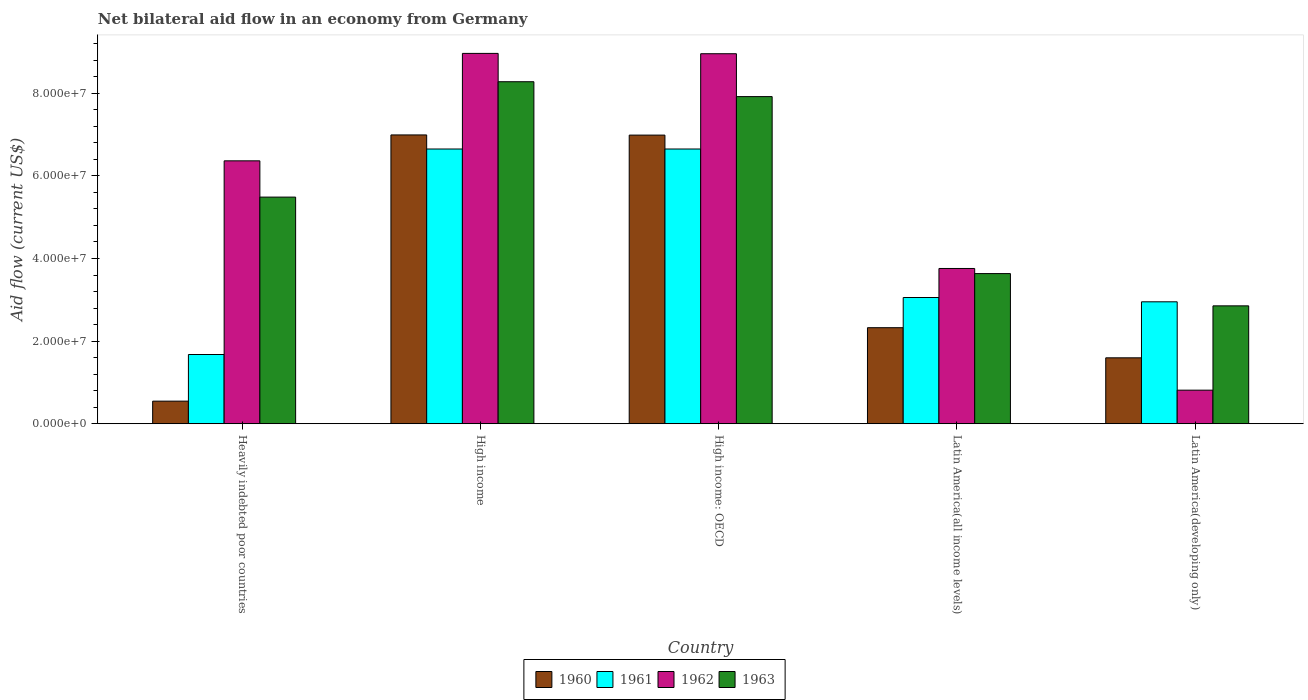How many different coloured bars are there?
Offer a terse response. 4. Are the number of bars per tick equal to the number of legend labels?
Give a very brief answer. Yes. Are the number of bars on each tick of the X-axis equal?
Offer a terse response. Yes. What is the label of the 3rd group of bars from the left?
Your answer should be compact. High income: OECD. What is the net bilateral aid flow in 1963 in Latin America(all income levels)?
Your response must be concise. 3.64e+07. Across all countries, what is the maximum net bilateral aid flow in 1963?
Keep it short and to the point. 8.28e+07. Across all countries, what is the minimum net bilateral aid flow in 1963?
Make the answer very short. 2.85e+07. In which country was the net bilateral aid flow in 1963 minimum?
Ensure brevity in your answer.  Latin America(developing only). What is the total net bilateral aid flow in 1962 in the graph?
Provide a short and direct response. 2.89e+08. What is the difference between the net bilateral aid flow in 1962 in Heavily indebted poor countries and that in Latin America(developing only)?
Ensure brevity in your answer.  5.55e+07. What is the difference between the net bilateral aid flow in 1962 in High income and the net bilateral aid flow in 1960 in High income: OECD?
Provide a succinct answer. 1.98e+07. What is the average net bilateral aid flow in 1960 per country?
Your answer should be very brief. 3.69e+07. What is the difference between the net bilateral aid flow of/in 1963 and net bilateral aid flow of/in 1962 in High income?
Offer a very short reply. -6.86e+06. What is the ratio of the net bilateral aid flow in 1962 in Latin America(all income levels) to that in Latin America(developing only)?
Offer a very short reply. 4.62. Is the net bilateral aid flow in 1961 in Heavily indebted poor countries less than that in Latin America(all income levels)?
Provide a succinct answer. Yes. What is the difference between the highest and the second highest net bilateral aid flow in 1963?
Offer a very short reply. 3.60e+06. What is the difference between the highest and the lowest net bilateral aid flow in 1962?
Give a very brief answer. 8.15e+07. In how many countries, is the net bilateral aid flow in 1961 greater than the average net bilateral aid flow in 1961 taken over all countries?
Offer a very short reply. 2. Is it the case that in every country, the sum of the net bilateral aid flow in 1961 and net bilateral aid flow in 1963 is greater than the sum of net bilateral aid flow in 1962 and net bilateral aid flow in 1960?
Your answer should be very brief. No. What does the 2nd bar from the left in High income: OECD represents?
Keep it short and to the point. 1961. What does the 3rd bar from the right in Latin America(developing only) represents?
Give a very brief answer. 1961. Is it the case that in every country, the sum of the net bilateral aid flow in 1961 and net bilateral aid flow in 1960 is greater than the net bilateral aid flow in 1962?
Your response must be concise. No. How many countries are there in the graph?
Provide a short and direct response. 5. Does the graph contain grids?
Provide a short and direct response. No. What is the title of the graph?
Provide a short and direct response. Net bilateral aid flow in an economy from Germany. What is the label or title of the Y-axis?
Ensure brevity in your answer.  Aid flow (current US$). What is the Aid flow (current US$) of 1960 in Heavily indebted poor countries?
Provide a short and direct response. 5.47e+06. What is the Aid flow (current US$) of 1961 in Heavily indebted poor countries?
Your answer should be very brief. 1.68e+07. What is the Aid flow (current US$) of 1962 in Heavily indebted poor countries?
Offer a very short reply. 6.36e+07. What is the Aid flow (current US$) in 1963 in Heavily indebted poor countries?
Keep it short and to the point. 5.49e+07. What is the Aid flow (current US$) of 1960 in High income?
Keep it short and to the point. 6.99e+07. What is the Aid flow (current US$) in 1961 in High income?
Make the answer very short. 6.65e+07. What is the Aid flow (current US$) in 1962 in High income?
Offer a very short reply. 8.97e+07. What is the Aid flow (current US$) of 1963 in High income?
Offer a very short reply. 8.28e+07. What is the Aid flow (current US$) in 1960 in High income: OECD?
Provide a succinct answer. 6.99e+07. What is the Aid flow (current US$) in 1961 in High income: OECD?
Your response must be concise. 6.65e+07. What is the Aid flow (current US$) of 1962 in High income: OECD?
Keep it short and to the point. 8.96e+07. What is the Aid flow (current US$) in 1963 in High income: OECD?
Make the answer very short. 7.92e+07. What is the Aid flow (current US$) of 1960 in Latin America(all income levels)?
Your answer should be compact. 2.32e+07. What is the Aid flow (current US$) in 1961 in Latin America(all income levels)?
Keep it short and to the point. 3.06e+07. What is the Aid flow (current US$) in 1962 in Latin America(all income levels)?
Offer a terse response. 3.76e+07. What is the Aid flow (current US$) in 1963 in Latin America(all income levels)?
Provide a short and direct response. 3.64e+07. What is the Aid flow (current US$) in 1960 in Latin America(developing only)?
Offer a terse response. 1.60e+07. What is the Aid flow (current US$) in 1961 in Latin America(developing only)?
Give a very brief answer. 2.95e+07. What is the Aid flow (current US$) of 1962 in Latin America(developing only)?
Make the answer very short. 8.13e+06. What is the Aid flow (current US$) of 1963 in Latin America(developing only)?
Give a very brief answer. 2.85e+07. Across all countries, what is the maximum Aid flow (current US$) of 1960?
Provide a short and direct response. 6.99e+07. Across all countries, what is the maximum Aid flow (current US$) of 1961?
Your answer should be compact. 6.65e+07. Across all countries, what is the maximum Aid flow (current US$) of 1962?
Offer a very short reply. 8.97e+07. Across all countries, what is the maximum Aid flow (current US$) of 1963?
Ensure brevity in your answer.  8.28e+07. Across all countries, what is the minimum Aid flow (current US$) in 1960?
Your answer should be compact. 5.47e+06. Across all countries, what is the minimum Aid flow (current US$) of 1961?
Give a very brief answer. 1.68e+07. Across all countries, what is the minimum Aid flow (current US$) of 1962?
Give a very brief answer. 8.13e+06. Across all countries, what is the minimum Aid flow (current US$) in 1963?
Offer a very short reply. 2.85e+07. What is the total Aid flow (current US$) in 1960 in the graph?
Keep it short and to the point. 1.84e+08. What is the total Aid flow (current US$) of 1961 in the graph?
Provide a short and direct response. 2.10e+08. What is the total Aid flow (current US$) in 1962 in the graph?
Keep it short and to the point. 2.89e+08. What is the total Aid flow (current US$) of 1963 in the graph?
Offer a very short reply. 2.82e+08. What is the difference between the Aid flow (current US$) in 1960 in Heavily indebted poor countries and that in High income?
Offer a very short reply. -6.44e+07. What is the difference between the Aid flow (current US$) of 1961 in Heavily indebted poor countries and that in High income?
Your answer should be very brief. -4.98e+07. What is the difference between the Aid flow (current US$) in 1962 in Heavily indebted poor countries and that in High income?
Your answer should be very brief. -2.60e+07. What is the difference between the Aid flow (current US$) in 1963 in Heavily indebted poor countries and that in High income?
Your response must be concise. -2.79e+07. What is the difference between the Aid flow (current US$) in 1960 in Heavily indebted poor countries and that in High income: OECD?
Your response must be concise. -6.44e+07. What is the difference between the Aid flow (current US$) of 1961 in Heavily indebted poor countries and that in High income: OECD?
Provide a succinct answer. -4.98e+07. What is the difference between the Aid flow (current US$) of 1962 in Heavily indebted poor countries and that in High income: OECD?
Your answer should be very brief. -2.59e+07. What is the difference between the Aid flow (current US$) of 1963 in Heavily indebted poor countries and that in High income: OECD?
Keep it short and to the point. -2.43e+07. What is the difference between the Aid flow (current US$) in 1960 in Heavily indebted poor countries and that in Latin America(all income levels)?
Offer a terse response. -1.78e+07. What is the difference between the Aid flow (current US$) in 1961 in Heavily indebted poor countries and that in Latin America(all income levels)?
Offer a very short reply. -1.38e+07. What is the difference between the Aid flow (current US$) in 1962 in Heavily indebted poor countries and that in Latin America(all income levels)?
Your response must be concise. 2.61e+07. What is the difference between the Aid flow (current US$) in 1963 in Heavily indebted poor countries and that in Latin America(all income levels)?
Offer a very short reply. 1.85e+07. What is the difference between the Aid flow (current US$) in 1960 in Heavily indebted poor countries and that in Latin America(developing only)?
Your response must be concise. -1.05e+07. What is the difference between the Aid flow (current US$) of 1961 in Heavily indebted poor countries and that in Latin America(developing only)?
Make the answer very short. -1.28e+07. What is the difference between the Aid flow (current US$) in 1962 in Heavily indebted poor countries and that in Latin America(developing only)?
Provide a succinct answer. 5.55e+07. What is the difference between the Aid flow (current US$) of 1963 in Heavily indebted poor countries and that in Latin America(developing only)?
Give a very brief answer. 2.63e+07. What is the difference between the Aid flow (current US$) in 1960 in High income and that in High income: OECD?
Offer a terse response. 4.00e+04. What is the difference between the Aid flow (current US$) in 1963 in High income and that in High income: OECD?
Provide a short and direct response. 3.60e+06. What is the difference between the Aid flow (current US$) in 1960 in High income and that in Latin America(all income levels)?
Make the answer very short. 4.67e+07. What is the difference between the Aid flow (current US$) in 1961 in High income and that in Latin America(all income levels)?
Your answer should be compact. 3.60e+07. What is the difference between the Aid flow (current US$) of 1962 in High income and that in Latin America(all income levels)?
Offer a terse response. 5.21e+07. What is the difference between the Aid flow (current US$) in 1963 in High income and that in Latin America(all income levels)?
Provide a succinct answer. 4.64e+07. What is the difference between the Aid flow (current US$) of 1960 in High income and that in Latin America(developing only)?
Your response must be concise. 5.40e+07. What is the difference between the Aid flow (current US$) in 1961 in High income and that in Latin America(developing only)?
Your answer should be very brief. 3.70e+07. What is the difference between the Aid flow (current US$) of 1962 in High income and that in Latin America(developing only)?
Your answer should be very brief. 8.15e+07. What is the difference between the Aid flow (current US$) in 1963 in High income and that in Latin America(developing only)?
Offer a very short reply. 5.43e+07. What is the difference between the Aid flow (current US$) in 1960 in High income: OECD and that in Latin America(all income levels)?
Offer a terse response. 4.66e+07. What is the difference between the Aid flow (current US$) of 1961 in High income: OECD and that in Latin America(all income levels)?
Make the answer very short. 3.60e+07. What is the difference between the Aid flow (current US$) in 1962 in High income: OECD and that in Latin America(all income levels)?
Your response must be concise. 5.20e+07. What is the difference between the Aid flow (current US$) in 1963 in High income: OECD and that in Latin America(all income levels)?
Offer a terse response. 4.28e+07. What is the difference between the Aid flow (current US$) in 1960 in High income: OECD and that in Latin America(developing only)?
Your answer should be compact. 5.39e+07. What is the difference between the Aid flow (current US$) of 1961 in High income: OECD and that in Latin America(developing only)?
Ensure brevity in your answer.  3.70e+07. What is the difference between the Aid flow (current US$) in 1962 in High income: OECD and that in Latin America(developing only)?
Keep it short and to the point. 8.14e+07. What is the difference between the Aid flow (current US$) in 1963 in High income: OECD and that in Latin America(developing only)?
Offer a terse response. 5.07e+07. What is the difference between the Aid flow (current US$) of 1960 in Latin America(all income levels) and that in Latin America(developing only)?
Provide a short and direct response. 7.29e+06. What is the difference between the Aid flow (current US$) of 1961 in Latin America(all income levels) and that in Latin America(developing only)?
Make the answer very short. 1.04e+06. What is the difference between the Aid flow (current US$) in 1962 in Latin America(all income levels) and that in Latin America(developing only)?
Offer a very short reply. 2.95e+07. What is the difference between the Aid flow (current US$) in 1963 in Latin America(all income levels) and that in Latin America(developing only)?
Provide a short and direct response. 7.81e+06. What is the difference between the Aid flow (current US$) in 1960 in Heavily indebted poor countries and the Aid flow (current US$) in 1961 in High income?
Provide a short and direct response. -6.10e+07. What is the difference between the Aid flow (current US$) of 1960 in Heavily indebted poor countries and the Aid flow (current US$) of 1962 in High income?
Ensure brevity in your answer.  -8.42e+07. What is the difference between the Aid flow (current US$) of 1960 in Heavily indebted poor countries and the Aid flow (current US$) of 1963 in High income?
Your answer should be very brief. -7.73e+07. What is the difference between the Aid flow (current US$) of 1961 in Heavily indebted poor countries and the Aid flow (current US$) of 1962 in High income?
Provide a succinct answer. -7.29e+07. What is the difference between the Aid flow (current US$) of 1961 in Heavily indebted poor countries and the Aid flow (current US$) of 1963 in High income?
Offer a very short reply. -6.60e+07. What is the difference between the Aid flow (current US$) in 1962 in Heavily indebted poor countries and the Aid flow (current US$) in 1963 in High income?
Your answer should be compact. -1.92e+07. What is the difference between the Aid flow (current US$) of 1960 in Heavily indebted poor countries and the Aid flow (current US$) of 1961 in High income: OECD?
Ensure brevity in your answer.  -6.10e+07. What is the difference between the Aid flow (current US$) in 1960 in Heavily indebted poor countries and the Aid flow (current US$) in 1962 in High income: OECD?
Offer a terse response. -8.41e+07. What is the difference between the Aid flow (current US$) of 1960 in Heavily indebted poor countries and the Aid flow (current US$) of 1963 in High income: OECD?
Provide a short and direct response. -7.37e+07. What is the difference between the Aid flow (current US$) of 1961 in Heavily indebted poor countries and the Aid flow (current US$) of 1962 in High income: OECD?
Your response must be concise. -7.28e+07. What is the difference between the Aid flow (current US$) in 1961 in Heavily indebted poor countries and the Aid flow (current US$) in 1963 in High income: OECD?
Provide a succinct answer. -6.24e+07. What is the difference between the Aid flow (current US$) in 1962 in Heavily indebted poor countries and the Aid flow (current US$) in 1963 in High income: OECD?
Make the answer very short. -1.56e+07. What is the difference between the Aid flow (current US$) of 1960 in Heavily indebted poor countries and the Aid flow (current US$) of 1961 in Latin America(all income levels)?
Your answer should be very brief. -2.51e+07. What is the difference between the Aid flow (current US$) in 1960 in Heavily indebted poor countries and the Aid flow (current US$) in 1962 in Latin America(all income levels)?
Make the answer very short. -3.21e+07. What is the difference between the Aid flow (current US$) in 1960 in Heavily indebted poor countries and the Aid flow (current US$) in 1963 in Latin America(all income levels)?
Offer a very short reply. -3.09e+07. What is the difference between the Aid flow (current US$) in 1961 in Heavily indebted poor countries and the Aid flow (current US$) in 1962 in Latin America(all income levels)?
Your answer should be very brief. -2.08e+07. What is the difference between the Aid flow (current US$) in 1961 in Heavily indebted poor countries and the Aid flow (current US$) in 1963 in Latin America(all income levels)?
Provide a succinct answer. -1.96e+07. What is the difference between the Aid flow (current US$) in 1962 in Heavily indebted poor countries and the Aid flow (current US$) in 1963 in Latin America(all income levels)?
Provide a succinct answer. 2.73e+07. What is the difference between the Aid flow (current US$) in 1960 in Heavily indebted poor countries and the Aid flow (current US$) in 1961 in Latin America(developing only)?
Your response must be concise. -2.40e+07. What is the difference between the Aid flow (current US$) in 1960 in Heavily indebted poor countries and the Aid flow (current US$) in 1962 in Latin America(developing only)?
Your response must be concise. -2.66e+06. What is the difference between the Aid flow (current US$) of 1960 in Heavily indebted poor countries and the Aid flow (current US$) of 1963 in Latin America(developing only)?
Give a very brief answer. -2.31e+07. What is the difference between the Aid flow (current US$) of 1961 in Heavily indebted poor countries and the Aid flow (current US$) of 1962 in Latin America(developing only)?
Your response must be concise. 8.63e+06. What is the difference between the Aid flow (current US$) of 1961 in Heavily indebted poor countries and the Aid flow (current US$) of 1963 in Latin America(developing only)?
Provide a short and direct response. -1.18e+07. What is the difference between the Aid flow (current US$) of 1962 in Heavily indebted poor countries and the Aid flow (current US$) of 1963 in Latin America(developing only)?
Keep it short and to the point. 3.51e+07. What is the difference between the Aid flow (current US$) of 1960 in High income and the Aid flow (current US$) of 1961 in High income: OECD?
Offer a very short reply. 3.41e+06. What is the difference between the Aid flow (current US$) in 1960 in High income and the Aid flow (current US$) in 1962 in High income: OECD?
Give a very brief answer. -1.97e+07. What is the difference between the Aid flow (current US$) of 1960 in High income and the Aid flow (current US$) of 1963 in High income: OECD?
Your answer should be compact. -9.28e+06. What is the difference between the Aid flow (current US$) in 1961 in High income and the Aid flow (current US$) in 1962 in High income: OECD?
Offer a very short reply. -2.31e+07. What is the difference between the Aid flow (current US$) in 1961 in High income and the Aid flow (current US$) in 1963 in High income: OECD?
Provide a succinct answer. -1.27e+07. What is the difference between the Aid flow (current US$) in 1962 in High income and the Aid flow (current US$) in 1963 in High income: OECD?
Ensure brevity in your answer.  1.05e+07. What is the difference between the Aid flow (current US$) in 1960 in High income and the Aid flow (current US$) in 1961 in Latin America(all income levels)?
Ensure brevity in your answer.  3.94e+07. What is the difference between the Aid flow (current US$) of 1960 in High income and the Aid flow (current US$) of 1962 in Latin America(all income levels)?
Provide a short and direct response. 3.23e+07. What is the difference between the Aid flow (current US$) of 1960 in High income and the Aid flow (current US$) of 1963 in Latin America(all income levels)?
Your answer should be compact. 3.36e+07. What is the difference between the Aid flow (current US$) in 1961 in High income and the Aid flow (current US$) in 1962 in Latin America(all income levels)?
Keep it short and to the point. 2.89e+07. What is the difference between the Aid flow (current US$) of 1961 in High income and the Aid flow (current US$) of 1963 in Latin America(all income levels)?
Your answer should be very brief. 3.02e+07. What is the difference between the Aid flow (current US$) in 1962 in High income and the Aid flow (current US$) in 1963 in Latin America(all income levels)?
Offer a terse response. 5.33e+07. What is the difference between the Aid flow (current US$) of 1960 in High income and the Aid flow (current US$) of 1961 in Latin America(developing only)?
Keep it short and to the point. 4.04e+07. What is the difference between the Aid flow (current US$) of 1960 in High income and the Aid flow (current US$) of 1962 in Latin America(developing only)?
Provide a succinct answer. 6.18e+07. What is the difference between the Aid flow (current US$) in 1960 in High income and the Aid flow (current US$) in 1963 in Latin America(developing only)?
Offer a terse response. 4.14e+07. What is the difference between the Aid flow (current US$) of 1961 in High income and the Aid flow (current US$) of 1962 in Latin America(developing only)?
Offer a terse response. 5.84e+07. What is the difference between the Aid flow (current US$) of 1961 in High income and the Aid flow (current US$) of 1963 in Latin America(developing only)?
Keep it short and to the point. 3.80e+07. What is the difference between the Aid flow (current US$) of 1962 in High income and the Aid flow (current US$) of 1963 in Latin America(developing only)?
Make the answer very short. 6.11e+07. What is the difference between the Aid flow (current US$) in 1960 in High income: OECD and the Aid flow (current US$) in 1961 in Latin America(all income levels)?
Provide a short and direct response. 3.93e+07. What is the difference between the Aid flow (current US$) in 1960 in High income: OECD and the Aid flow (current US$) in 1962 in Latin America(all income levels)?
Offer a terse response. 3.23e+07. What is the difference between the Aid flow (current US$) in 1960 in High income: OECD and the Aid flow (current US$) in 1963 in Latin America(all income levels)?
Keep it short and to the point. 3.35e+07. What is the difference between the Aid flow (current US$) of 1961 in High income: OECD and the Aid flow (current US$) of 1962 in Latin America(all income levels)?
Give a very brief answer. 2.89e+07. What is the difference between the Aid flow (current US$) of 1961 in High income: OECD and the Aid flow (current US$) of 1963 in Latin America(all income levels)?
Make the answer very short. 3.02e+07. What is the difference between the Aid flow (current US$) in 1962 in High income: OECD and the Aid flow (current US$) in 1963 in Latin America(all income levels)?
Keep it short and to the point. 5.32e+07. What is the difference between the Aid flow (current US$) of 1960 in High income: OECD and the Aid flow (current US$) of 1961 in Latin America(developing only)?
Provide a succinct answer. 4.04e+07. What is the difference between the Aid flow (current US$) of 1960 in High income: OECD and the Aid flow (current US$) of 1962 in Latin America(developing only)?
Your response must be concise. 6.18e+07. What is the difference between the Aid flow (current US$) of 1960 in High income: OECD and the Aid flow (current US$) of 1963 in Latin America(developing only)?
Your answer should be very brief. 4.13e+07. What is the difference between the Aid flow (current US$) of 1961 in High income: OECD and the Aid flow (current US$) of 1962 in Latin America(developing only)?
Keep it short and to the point. 5.84e+07. What is the difference between the Aid flow (current US$) in 1961 in High income: OECD and the Aid flow (current US$) in 1963 in Latin America(developing only)?
Keep it short and to the point. 3.80e+07. What is the difference between the Aid flow (current US$) in 1962 in High income: OECD and the Aid flow (current US$) in 1963 in Latin America(developing only)?
Offer a terse response. 6.10e+07. What is the difference between the Aid flow (current US$) of 1960 in Latin America(all income levels) and the Aid flow (current US$) of 1961 in Latin America(developing only)?
Give a very brief answer. -6.27e+06. What is the difference between the Aid flow (current US$) of 1960 in Latin America(all income levels) and the Aid flow (current US$) of 1962 in Latin America(developing only)?
Provide a short and direct response. 1.51e+07. What is the difference between the Aid flow (current US$) of 1960 in Latin America(all income levels) and the Aid flow (current US$) of 1963 in Latin America(developing only)?
Your response must be concise. -5.29e+06. What is the difference between the Aid flow (current US$) of 1961 in Latin America(all income levels) and the Aid flow (current US$) of 1962 in Latin America(developing only)?
Your answer should be compact. 2.24e+07. What is the difference between the Aid flow (current US$) in 1961 in Latin America(all income levels) and the Aid flow (current US$) in 1963 in Latin America(developing only)?
Your response must be concise. 2.02e+06. What is the difference between the Aid flow (current US$) in 1962 in Latin America(all income levels) and the Aid flow (current US$) in 1963 in Latin America(developing only)?
Your response must be concise. 9.05e+06. What is the average Aid flow (current US$) in 1960 per country?
Your answer should be very brief. 3.69e+07. What is the average Aid flow (current US$) of 1961 per country?
Provide a succinct answer. 4.20e+07. What is the average Aid flow (current US$) of 1962 per country?
Make the answer very short. 5.77e+07. What is the average Aid flow (current US$) of 1963 per country?
Give a very brief answer. 5.64e+07. What is the difference between the Aid flow (current US$) in 1960 and Aid flow (current US$) in 1961 in Heavily indebted poor countries?
Your response must be concise. -1.13e+07. What is the difference between the Aid flow (current US$) of 1960 and Aid flow (current US$) of 1962 in Heavily indebted poor countries?
Give a very brief answer. -5.82e+07. What is the difference between the Aid flow (current US$) of 1960 and Aid flow (current US$) of 1963 in Heavily indebted poor countries?
Your response must be concise. -4.94e+07. What is the difference between the Aid flow (current US$) of 1961 and Aid flow (current US$) of 1962 in Heavily indebted poor countries?
Provide a succinct answer. -4.69e+07. What is the difference between the Aid flow (current US$) of 1961 and Aid flow (current US$) of 1963 in Heavily indebted poor countries?
Provide a succinct answer. -3.81e+07. What is the difference between the Aid flow (current US$) of 1962 and Aid flow (current US$) of 1963 in Heavily indebted poor countries?
Your response must be concise. 8.78e+06. What is the difference between the Aid flow (current US$) of 1960 and Aid flow (current US$) of 1961 in High income?
Your response must be concise. 3.41e+06. What is the difference between the Aid flow (current US$) of 1960 and Aid flow (current US$) of 1962 in High income?
Your response must be concise. -1.97e+07. What is the difference between the Aid flow (current US$) in 1960 and Aid flow (current US$) in 1963 in High income?
Give a very brief answer. -1.29e+07. What is the difference between the Aid flow (current US$) in 1961 and Aid flow (current US$) in 1962 in High income?
Offer a terse response. -2.32e+07. What is the difference between the Aid flow (current US$) in 1961 and Aid flow (current US$) in 1963 in High income?
Make the answer very short. -1.63e+07. What is the difference between the Aid flow (current US$) of 1962 and Aid flow (current US$) of 1963 in High income?
Your answer should be compact. 6.86e+06. What is the difference between the Aid flow (current US$) of 1960 and Aid flow (current US$) of 1961 in High income: OECD?
Your answer should be very brief. 3.37e+06. What is the difference between the Aid flow (current US$) of 1960 and Aid flow (current US$) of 1962 in High income: OECD?
Provide a short and direct response. -1.97e+07. What is the difference between the Aid flow (current US$) in 1960 and Aid flow (current US$) in 1963 in High income: OECD?
Your answer should be compact. -9.32e+06. What is the difference between the Aid flow (current US$) of 1961 and Aid flow (current US$) of 1962 in High income: OECD?
Your answer should be compact. -2.31e+07. What is the difference between the Aid flow (current US$) in 1961 and Aid flow (current US$) in 1963 in High income: OECD?
Provide a short and direct response. -1.27e+07. What is the difference between the Aid flow (current US$) of 1962 and Aid flow (current US$) of 1963 in High income: OECD?
Ensure brevity in your answer.  1.04e+07. What is the difference between the Aid flow (current US$) in 1960 and Aid flow (current US$) in 1961 in Latin America(all income levels)?
Offer a terse response. -7.31e+06. What is the difference between the Aid flow (current US$) in 1960 and Aid flow (current US$) in 1962 in Latin America(all income levels)?
Ensure brevity in your answer.  -1.43e+07. What is the difference between the Aid flow (current US$) of 1960 and Aid flow (current US$) of 1963 in Latin America(all income levels)?
Provide a succinct answer. -1.31e+07. What is the difference between the Aid flow (current US$) of 1961 and Aid flow (current US$) of 1962 in Latin America(all income levels)?
Give a very brief answer. -7.03e+06. What is the difference between the Aid flow (current US$) in 1961 and Aid flow (current US$) in 1963 in Latin America(all income levels)?
Make the answer very short. -5.79e+06. What is the difference between the Aid flow (current US$) in 1962 and Aid flow (current US$) in 1963 in Latin America(all income levels)?
Your answer should be very brief. 1.24e+06. What is the difference between the Aid flow (current US$) in 1960 and Aid flow (current US$) in 1961 in Latin America(developing only)?
Make the answer very short. -1.36e+07. What is the difference between the Aid flow (current US$) of 1960 and Aid flow (current US$) of 1962 in Latin America(developing only)?
Your answer should be compact. 7.83e+06. What is the difference between the Aid flow (current US$) of 1960 and Aid flow (current US$) of 1963 in Latin America(developing only)?
Keep it short and to the point. -1.26e+07. What is the difference between the Aid flow (current US$) in 1961 and Aid flow (current US$) in 1962 in Latin America(developing only)?
Keep it short and to the point. 2.14e+07. What is the difference between the Aid flow (current US$) in 1961 and Aid flow (current US$) in 1963 in Latin America(developing only)?
Give a very brief answer. 9.80e+05. What is the difference between the Aid flow (current US$) in 1962 and Aid flow (current US$) in 1963 in Latin America(developing only)?
Offer a very short reply. -2.04e+07. What is the ratio of the Aid flow (current US$) of 1960 in Heavily indebted poor countries to that in High income?
Your answer should be very brief. 0.08. What is the ratio of the Aid flow (current US$) of 1961 in Heavily indebted poor countries to that in High income?
Provide a succinct answer. 0.25. What is the ratio of the Aid flow (current US$) of 1962 in Heavily indebted poor countries to that in High income?
Offer a very short reply. 0.71. What is the ratio of the Aid flow (current US$) of 1963 in Heavily indebted poor countries to that in High income?
Provide a short and direct response. 0.66. What is the ratio of the Aid flow (current US$) of 1960 in Heavily indebted poor countries to that in High income: OECD?
Offer a very short reply. 0.08. What is the ratio of the Aid flow (current US$) of 1961 in Heavily indebted poor countries to that in High income: OECD?
Ensure brevity in your answer.  0.25. What is the ratio of the Aid flow (current US$) in 1962 in Heavily indebted poor countries to that in High income: OECD?
Ensure brevity in your answer.  0.71. What is the ratio of the Aid flow (current US$) in 1963 in Heavily indebted poor countries to that in High income: OECD?
Your answer should be very brief. 0.69. What is the ratio of the Aid flow (current US$) of 1960 in Heavily indebted poor countries to that in Latin America(all income levels)?
Provide a short and direct response. 0.24. What is the ratio of the Aid flow (current US$) of 1961 in Heavily indebted poor countries to that in Latin America(all income levels)?
Offer a terse response. 0.55. What is the ratio of the Aid flow (current US$) in 1962 in Heavily indebted poor countries to that in Latin America(all income levels)?
Your response must be concise. 1.69. What is the ratio of the Aid flow (current US$) of 1963 in Heavily indebted poor countries to that in Latin America(all income levels)?
Make the answer very short. 1.51. What is the ratio of the Aid flow (current US$) in 1960 in Heavily indebted poor countries to that in Latin America(developing only)?
Your answer should be compact. 0.34. What is the ratio of the Aid flow (current US$) in 1961 in Heavily indebted poor countries to that in Latin America(developing only)?
Keep it short and to the point. 0.57. What is the ratio of the Aid flow (current US$) of 1962 in Heavily indebted poor countries to that in Latin America(developing only)?
Your answer should be compact. 7.83. What is the ratio of the Aid flow (current US$) in 1963 in Heavily indebted poor countries to that in Latin America(developing only)?
Keep it short and to the point. 1.92. What is the ratio of the Aid flow (current US$) in 1961 in High income to that in High income: OECD?
Your answer should be compact. 1. What is the ratio of the Aid flow (current US$) of 1962 in High income to that in High income: OECD?
Your answer should be compact. 1. What is the ratio of the Aid flow (current US$) in 1963 in High income to that in High income: OECD?
Provide a short and direct response. 1.05. What is the ratio of the Aid flow (current US$) of 1960 in High income to that in Latin America(all income levels)?
Provide a short and direct response. 3.01. What is the ratio of the Aid flow (current US$) of 1961 in High income to that in Latin America(all income levels)?
Offer a terse response. 2.18. What is the ratio of the Aid flow (current US$) in 1962 in High income to that in Latin America(all income levels)?
Keep it short and to the point. 2.39. What is the ratio of the Aid flow (current US$) in 1963 in High income to that in Latin America(all income levels)?
Make the answer very short. 2.28. What is the ratio of the Aid flow (current US$) in 1960 in High income to that in Latin America(developing only)?
Your answer should be very brief. 4.38. What is the ratio of the Aid flow (current US$) in 1961 in High income to that in Latin America(developing only)?
Offer a very short reply. 2.25. What is the ratio of the Aid flow (current US$) in 1962 in High income to that in Latin America(developing only)?
Ensure brevity in your answer.  11.03. What is the ratio of the Aid flow (current US$) of 1963 in High income to that in Latin America(developing only)?
Provide a succinct answer. 2.9. What is the ratio of the Aid flow (current US$) of 1960 in High income: OECD to that in Latin America(all income levels)?
Your answer should be compact. 3.01. What is the ratio of the Aid flow (current US$) in 1961 in High income: OECD to that in Latin America(all income levels)?
Keep it short and to the point. 2.18. What is the ratio of the Aid flow (current US$) in 1962 in High income: OECD to that in Latin America(all income levels)?
Your answer should be compact. 2.38. What is the ratio of the Aid flow (current US$) of 1963 in High income: OECD to that in Latin America(all income levels)?
Your answer should be compact. 2.18. What is the ratio of the Aid flow (current US$) in 1960 in High income: OECD to that in Latin America(developing only)?
Your response must be concise. 4.38. What is the ratio of the Aid flow (current US$) of 1961 in High income: OECD to that in Latin America(developing only)?
Give a very brief answer. 2.25. What is the ratio of the Aid flow (current US$) in 1962 in High income: OECD to that in Latin America(developing only)?
Give a very brief answer. 11.02. What is the ratio of the Aid flow (current US$) of 1963 in High income: OECD to that in Latin America(developing only)?
Your answer should be compact. 2.78. What is the ratio of the Aid flow (current US$) in 1960 in Latin America(all income levels) to that in Latin America(developing only)?
Your answer should be compact. 1.46. What is the ratio of the Aid flow (current US$) in 1961 in Latin America(all income levels) to that in Latin America(developing only)?
Your answer should be compact. 1.04. What is the ratio of the Aid flow (current US$) of 1962 in Latin America(all income levels) to that in Latin America(developing only)?
Offer a terse response. 4.62. What is the ratio of the Aid flow (current US$) in 1963 in Latin America(all income levels) to that in Latin America(developing only)?
Offer a terse response. 1.27. What is the difference between the highest and the second highest Aid flow (current US$) of 1960?
Your answer should be very brief. 4.00e+04. What is the difference between the highest and the second highest Aid flow (current US$) in 1961?
Make the answer very short. 0. What is the difference between the highest and the second highest Aid flow (current US$) in 1963?
Your response must be concise. 3.60e+06. What is the difference between the highest and the lowest Aid flow (current US$) of 1960?
Make the answer very short. 6.44e+07. What is the difference between the highest and the lowest Aid flow (current US$) of 1961?
Your answer should be compact. 4.98e+07. What is the difference between the highest and the lowest Aid flow (current US$) in 1962?
Provide a short and direct response. 8.15e+07. What is the difference between the highest and the lowest Aid flow (current US$) of 1963?
Your response must be concise. 5.43e+07. 